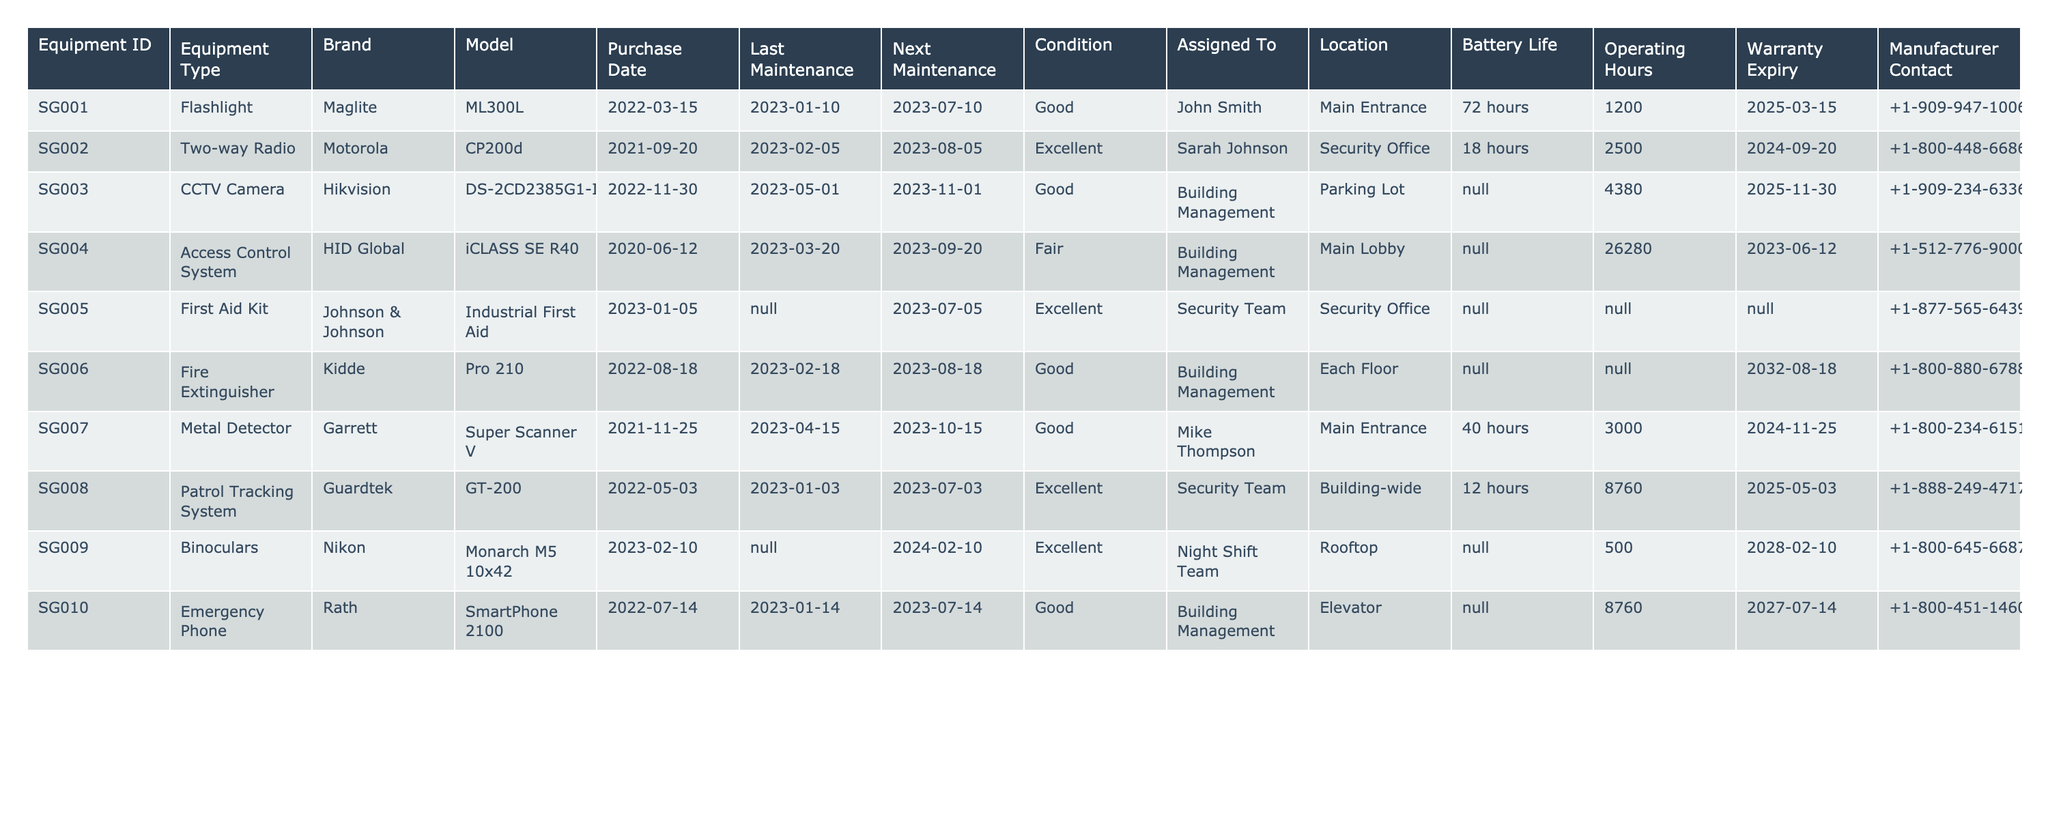What is the brand of the Fire Extinguisher? The table lists the equipment, and under the "Brand" column for the Fire Extinguisher (Equipment ID SG006), it shows "Kidde."
Answer: Kidde What is the condition of the Two-way Radio? Referring to the table, the condition for the Two-way Radio (Equipment ID SG002) is listed as "Excellent."
Answer: Excellent When is the next maintenance scheduled for the CCTV Camera? Looking at the Next Maintenance column, the next maintenance date for the CCTV Camera (Equipment ID SG003) is 2023-11-01.
Answer: 2023-11-01 Which equipment has the longest battery life? The battery lives listed are 72 hours (Flashlight), 18 hours (Two-way Radio), N/A (CCTV), N/A (Access Control), N/A (First Aid Kit), N/A (Fire Extinguisher), 40 hours (Metal Detector), 12 hours (Patrol Tracking), N/A (Binoculars), N/A (Emergency Phone). The longest battery life is 72 hours for the Flashlight.
Answer: 72 hours What is the total number of operating hours for the Access Control System? The operating hours for the Access Control System (Equipment ID SG004) is 26,280 hours as indicated in the table.
Answer: 26,280 Is the warranty for the First Aid Kit still valid? The warranty expiry date for the First Aid Kit (Equipment ID SG005) is marked as N/A, indicating that there is no warranty applicable. Therefore, it is not valid.
Answer: No Which equipment is assigned to the Security Team and what is its condition? According to the table, the equipment assigned to the Security Team is the First Aid Kit (SG005) with a condition of "Excellent" and the Patrol Tracking System (SG008) also in "Excellent" condition.
Answer: First Aid Kit (Excellent), Patrol Tracking System (Excellent) How many pieces of equipment have a condition of "Good"? The table indicates that there are three pieces of equipment with a condition of "Good": Flashlight, Fire Extinguisher, and Metal Detector.
Answer: 3 When was the Access Control System last maintained? The table shows that the last maintenance for the Access Control System (Equipment ID SG004) was on 2023-03-20.
Answer: 2023-03-20 Are there any pieces of equipment located on the rooftop? The table indicates that the Binoculars (Equipment ID SG009) are located on the rooftop. Therefore, yes, there is equipment on the rooftop.
Answer: Yes 